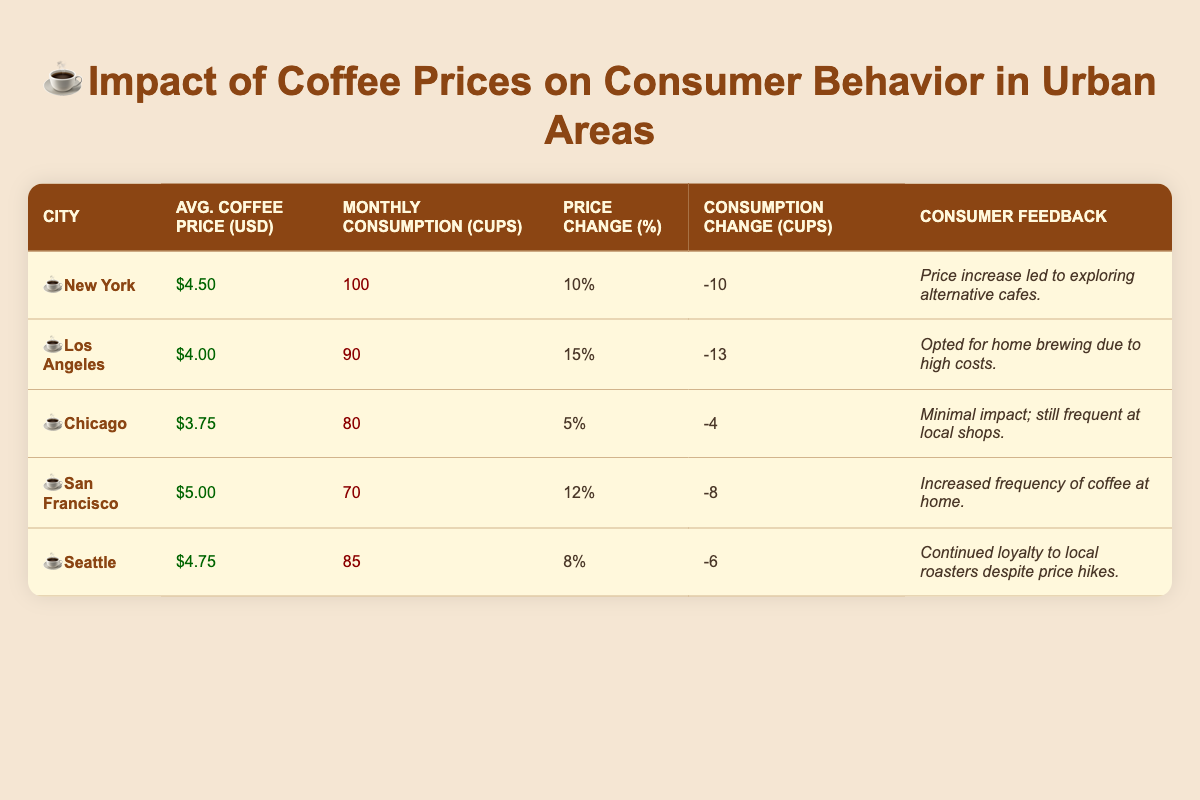What is the average coffee price in New York? The average coffee price for New York, found in the table, is listed directly under the corresponding city. It shows an average price of 4.50 USD.
Answer: 4.50 USD Which city had the highest percentage change in coffee price? By examining the column for percentage change, Los Angeles shows a 15% increase, which is higher than the percentages from all other cities listed.
Answer: Los Angeles How many cups of coffee do consumers in Seattle consume monthly? The table provides the "Monthly Consumption" value for Seattle, which is directly stated as 85 cups.
Answer: 85 cups What is the total change in coffee consumption for New York and San Francisco combined? For New York, the change in consumption is -10 cups, and for San Francisco, it is -8 cups. Adding these together gives a total change of -18 cups ( -10 + -8 = -18).
Answer: -18 cups Did consumers in Chicago report significant behavioral changes due to the price increase? The feedback for Chicago indicates minimal impact on consumer behavior despite a price increase; thus, the answer is no.
Answer: No What city has the lowest monthly coffee consumption and how many cups is it? By scanning the monthly consumption column, San Francisco at 70 cups is the city with the lowest consumption among those listed.
Answer: San Francisco, 70 cups What is the average change in consumption across all cities represented? To find the average change in consumption, sum all changes: (-10 + -13 + -4 + -8 + -6 = -41), then divide by the number of cities (5): -41/5 = -8.2). The average change in consumption is therefore -8.2 cups.
Answer: -8.2 cups Is it true that Seattle consumers have continued loyalty to local roasters despite price hikes? The feedback for Seattle clearly states that consumers continued their loyalty to local roasters, which confirms the statement as true.
Answer: Yes If the coffee price in Los Angeles were to increase by another 10%, what would the average price be? The current average price is 4.00 USD. A 10% increase would be calculated as 4.00 USD * 0.10 = 0.40 USD, making the new price 4.00 USD + 0.40 USD = 4.40 USD.
Answer: 4.40 USD 